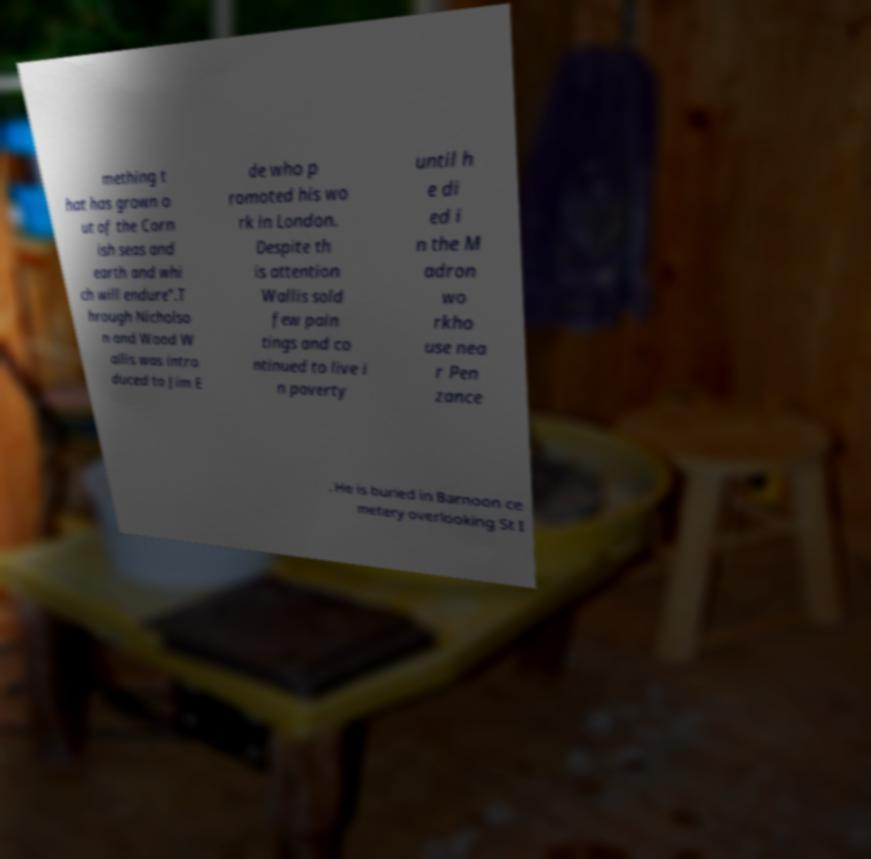I need the written content from this picture converted into text. Can you do that? mething t hat has grown o ut of the Corn ish seas and earth and whi ch will endure".T hrough Nicholso n and Wood W allis was intro duced to Jim E de who p romoted his wo rk in London. Despite th is attention Wallis sold few pain tings and co ntinued to live i n poverty until h e di ed i n the M adron wo rkho use nea r Pen zance . He is buried in Barnoon ce metery overlooking St I 